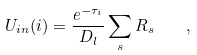Convert formula to latex. <formula><loc_0><loc_0><loc_500><loc_500>U _ { i n } ( i ) = \frac { e ^ { - \tau _ { i } } } { D _ { l } } \sum _ { s } R _ { s } \quad ,</formula> 